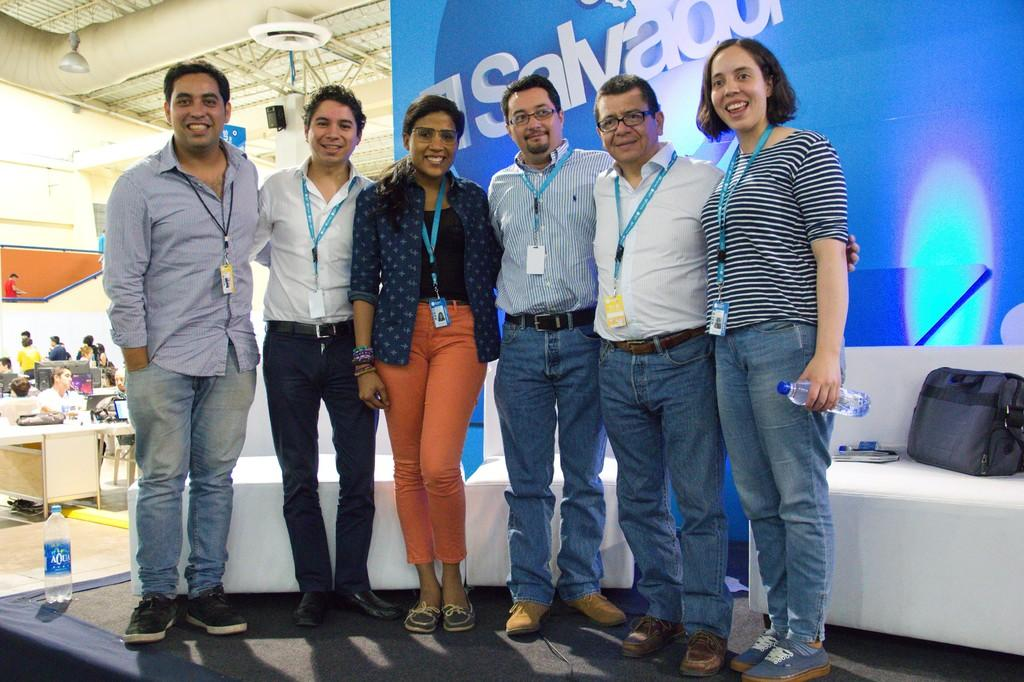What are the people in the foreground of the image doing? There is a group of people standing and posing for a photo in the foreground. What can be seen in the background of the image? There is a sofa and a banner in the background, as well as other people. What type of reward is being handed out to the representative in the image? There is no reward or representative present in the image. 